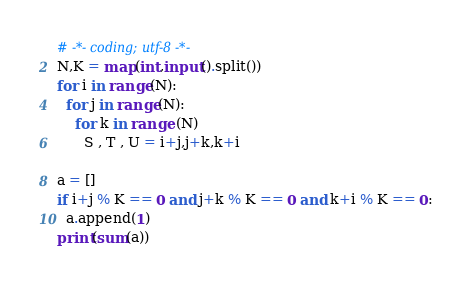Convert code to text. <code><loc_0><loc_0><loc_500><loc_500><_Python_># -*- coding; utf-8 -*-
N,K = map(int,input().split())
for i in range(N):
  for j in range(N):
    for k in range (N)
      S , T , U = i+j,j+k,k+i
      
a = []
if i+j % K == 0 and j+k % K == 0 and k+i % K == 0:
  a.append(1)
print(sum(a))</code> 